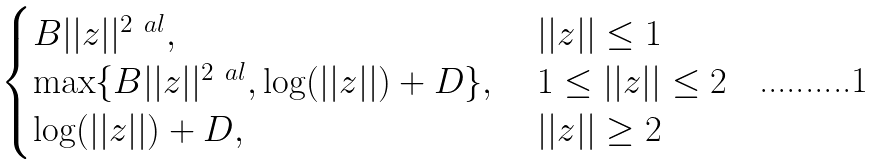<formula> <loc_0><loc_0><loc_500><loc_500>\begin{cases} B | | z | | ^ { 2 \ a l } , \ & | | z | | \leq 1 \\ \max \{ B | | z | | ^ { 2 \ a l } , \log ( | | z | | ) + D \} , \ & 1 \leq | | z | | \leq 2 \\ \log ( | | z | | ) + D , \ & | | z | | \geq 2 \end{cases}</formula> 